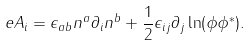Convert formula to latex. <formula><loc_0><loc_0><loc_500><loc_500>e A _ { i } = \epsilon _ { a b } n ^ { a } \partial _ { i } n ^ { b } + \frac { 1 } { 2 } \epsilon _ { i j } \partial _ { j } \ln ( \phi \phi ^ { \ast } ) .</formula> 